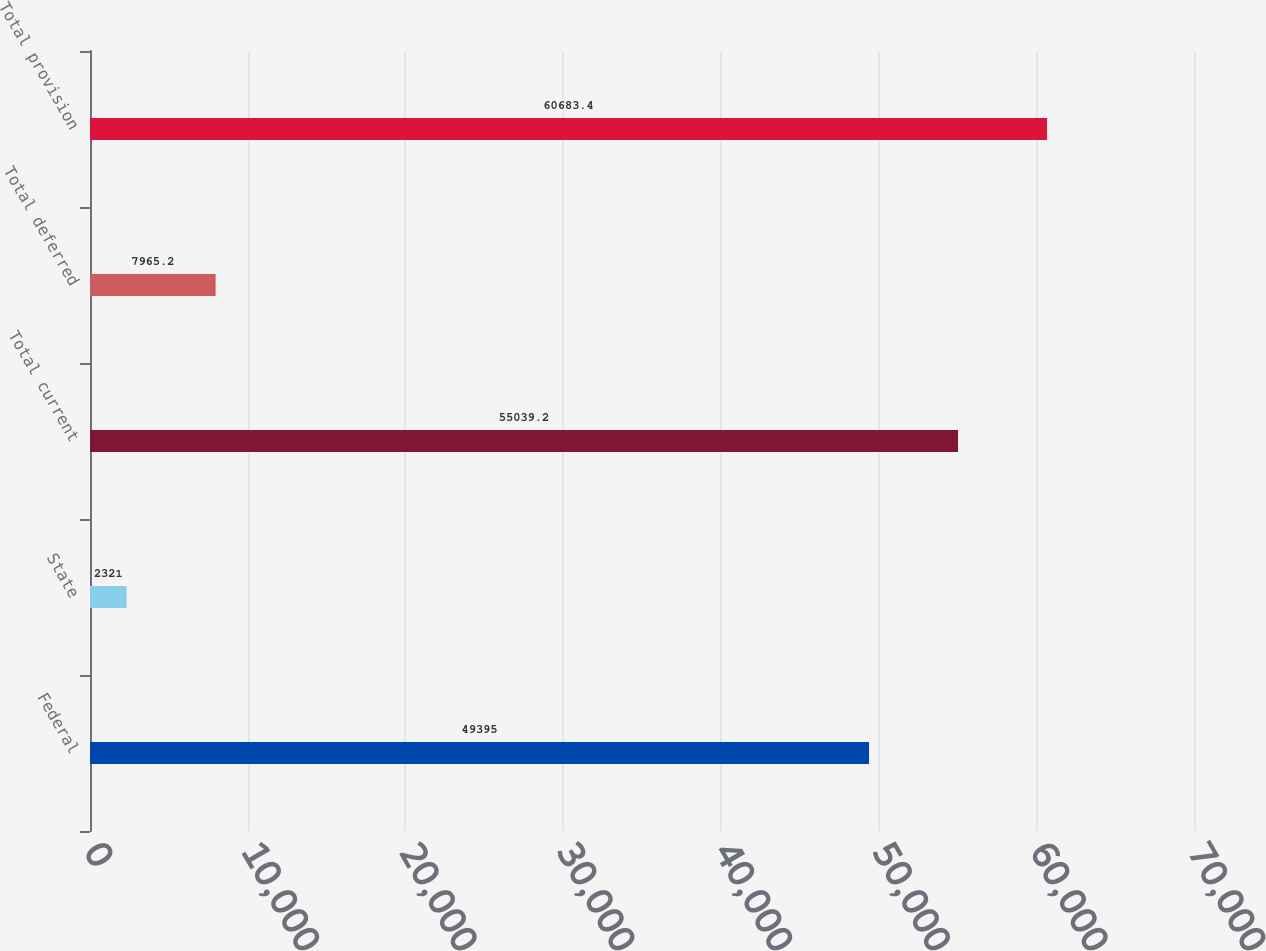Convert chart to OTSL. <chart><loc_0><loc_0><loc_500><loc_500><bar_chart><fcel>Federal<fcel>State<fcel>Total current<fcel>Total deferred<fcel>Total provision<nl><fcel>49395<fcel>2321<fcel>55039.2<fcel>7965.2<fcel>60683.4<nl></chart> 